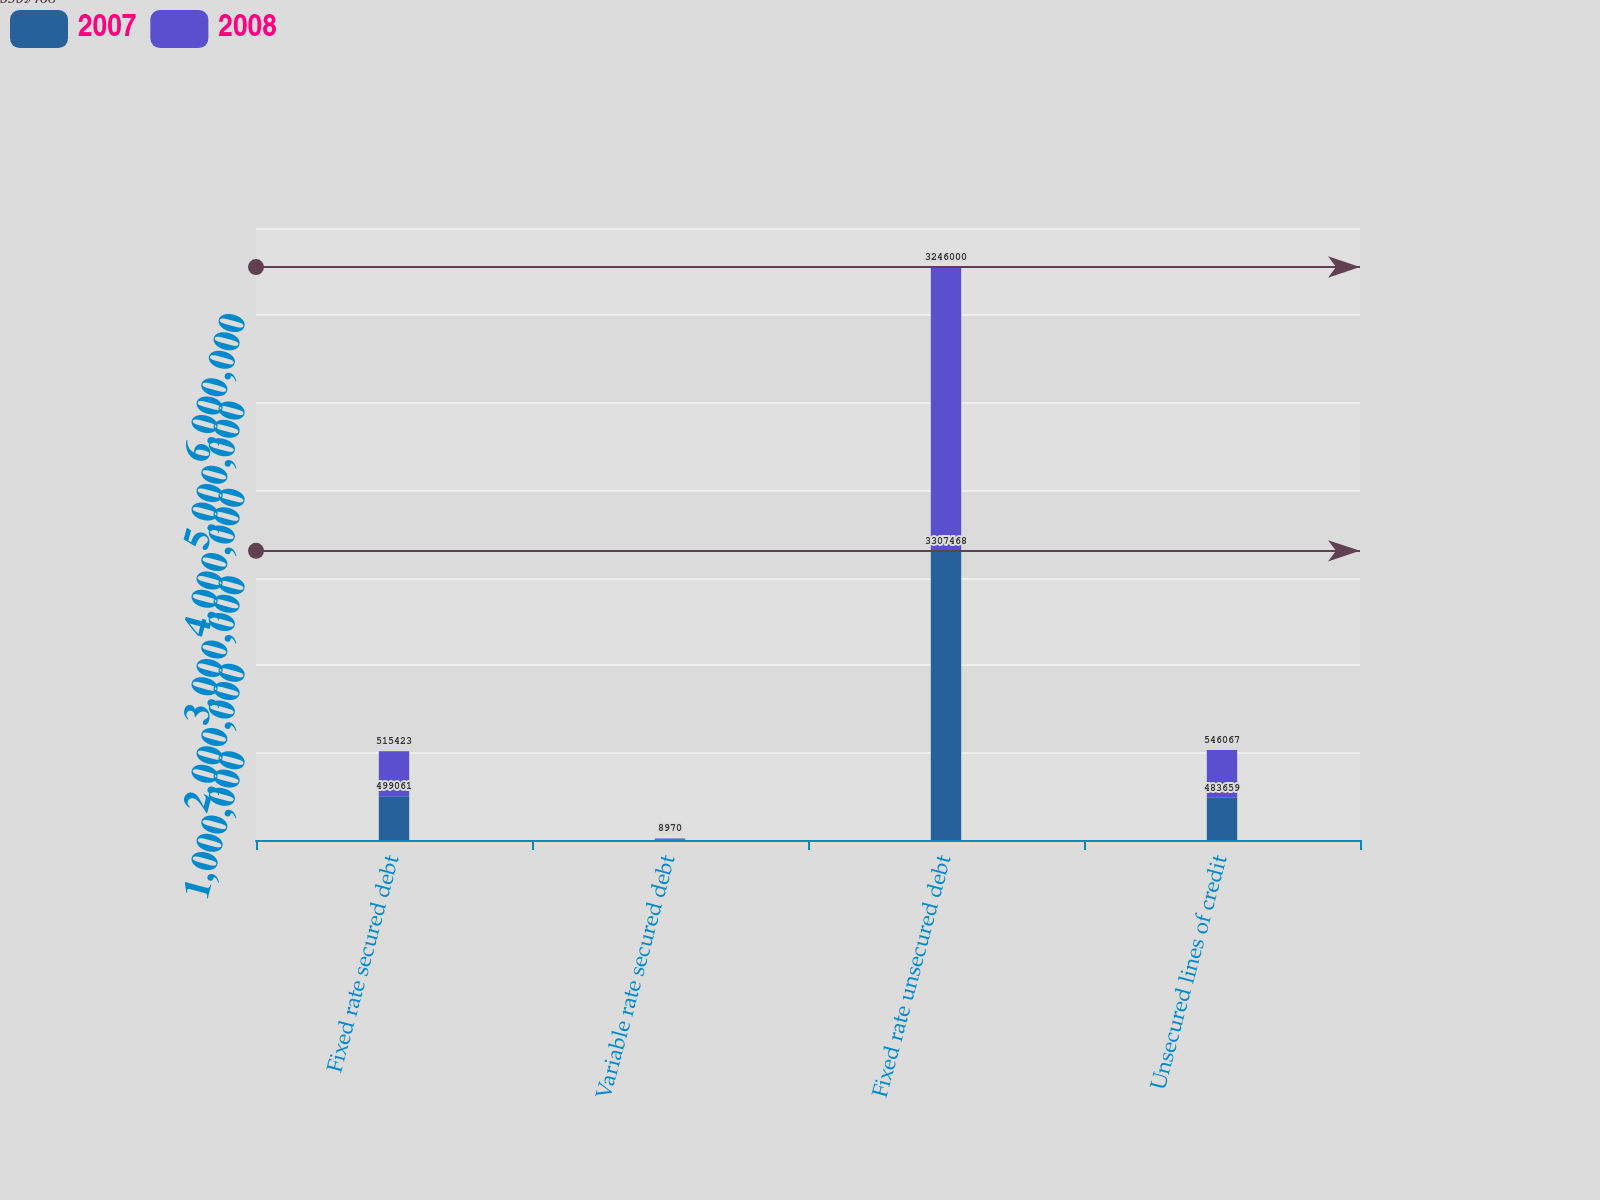Convert chart. <chart><loc_0><loc_0><loc_500><loc_500><stacked_bar_chart><ecel><fcel>Fixed rate secured debt<fcel>Variable rate secured debt<fcel>Fixed rate unsecured debt<fcel>Unsecured lines of credit<nl><fcel>2007<fcel>499061<fcel>8290<fcel>3.30747e+06<fcel>483659<nl><fcel>2008<fcel>515423<fcel>8970<fcel>3.246e+06<fcel>546067<nl></chart> 